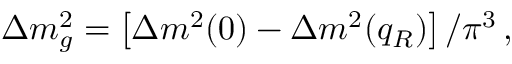<formula> <loc_0><loc_0><loc_500><loc_500>\Delta m _ { g } ^ { 2 } = \left [ \Delta m ^ { 2 } ( 0 ) - \Delta m ^ { 2 } ( q _ { R } ) \right ] / \pi ^ { 3 } \, ,</formula> 